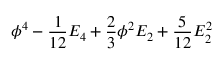Convert formula to latex. <formula><loc_0><loc_0><loc_500><loc_500>\phi ^ { 4 } - { \frac { 1 } { 1 2 } } E _ { 4 } + { \frac { 2 } { 3 } } \phi ^ { 2 } E _ { 2 } + { \frac { 5 } { 1 2 } } E _ { 2 } ^ { 2 }</formula> 